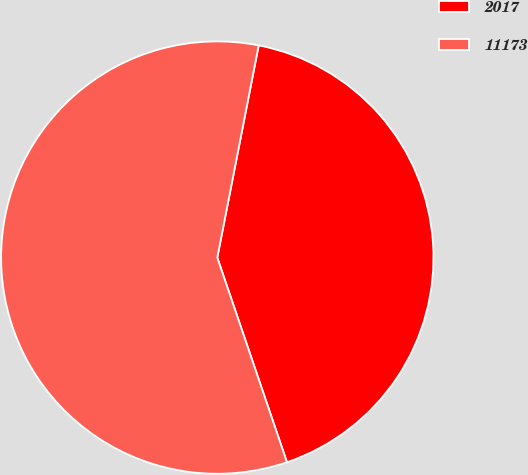Convert chart. <chart><loc_0><loc_0><loc_500><loc_500><pie_chart><fcel>2017<fcel>11173<nl><fcel>41.71%<fcel>58.29%<nl></chart> 